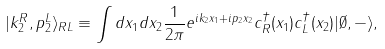<formula> <loc_0><loc_0><loc_500><loc_500>| k _ { 2 } ^ { R } , p _ { 2 } ^ { L } \rangle _ { R L } \equiv \int d x _ { 1 } d x _ { 2 } \frac { 1 } { 2 \pi } e ^ { i k _ { 2 } x _ { 1 } + i p _ { 2 } x _ { 2 } } c ^ { \dagger } _ { R } ( x _ { 1 } ) c ^ { \dagger } _ { L } ( x _ { 2 } ) | \emptyset , - \rangle ,</formula> 